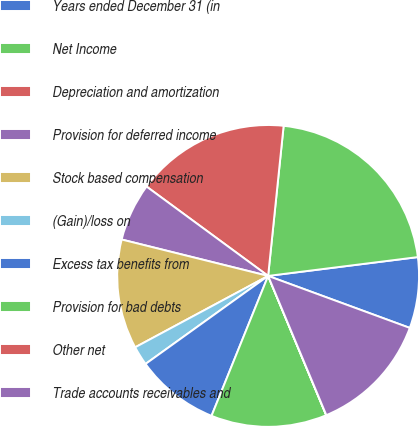Convert chart to OTSL. <chart><loc_0><loc_0><loc_500><loc_500><pie_chart><fcel>Years ended December 31 (in<fcel>Net Income<fcel>Depreciation and amortization<fcel>Provision for deferred income<fcel>Stock based compensation<fcel>(Gain)/loss on<fcel>Excess tax benefits from<fcel>Provision for bad debts<fcel>Other net<fcel>Trade accounts receivables and<nl><fcel>7.59%<fcel>21.37%<fcel>16.55%<fcel>6.21%<fcel>11.72%<fcel>2.07%<fcel>8.97%<fcel>12.41%<fcel>0.01%<fcel>13.1%<nl></chart> 